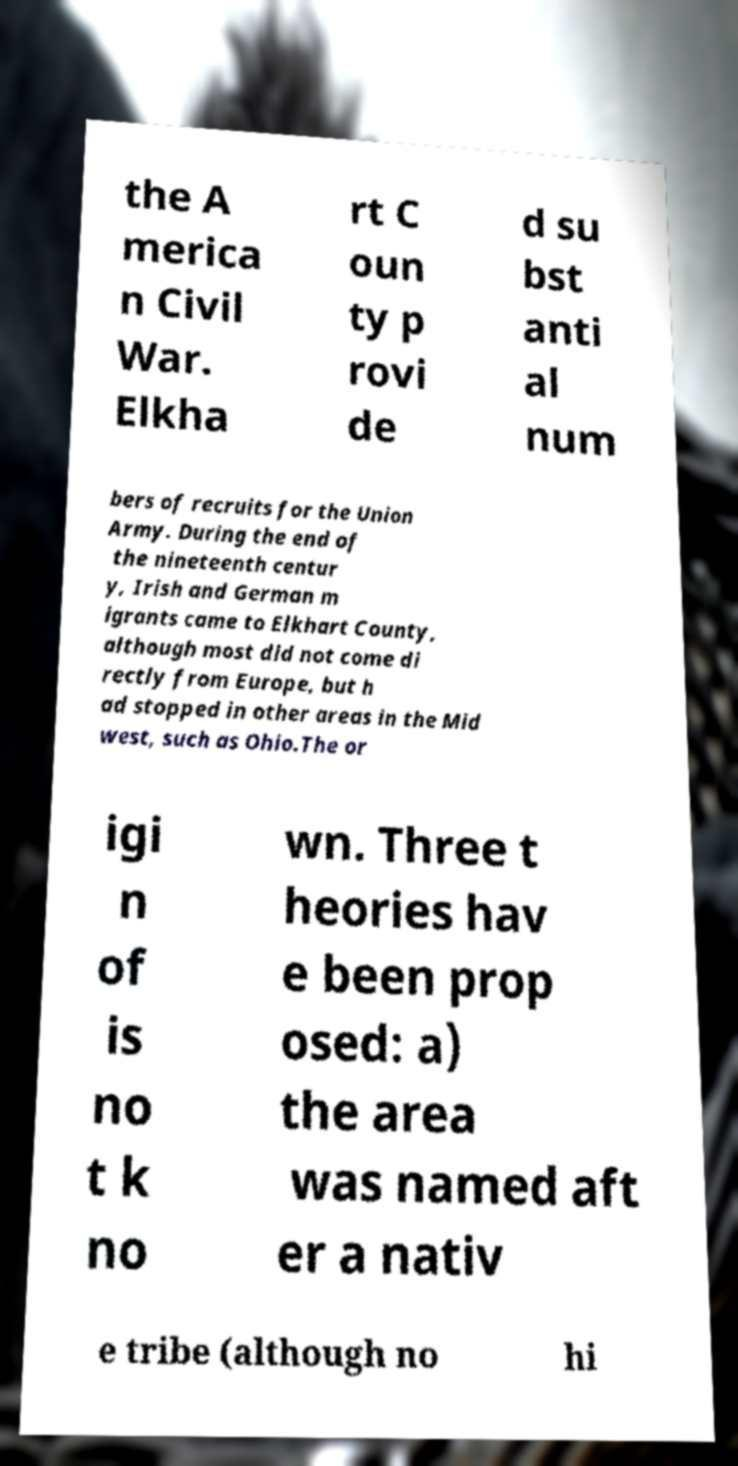I need the written content from this picture converted into text. Can you do that? the A merica n Civil War. Elkha rt C oun ty p rovi de d su bst anti al num bers of recruits for the Union Army. During the end of the nineteenth centur y, Irish and German m igrants came to Elkhart County, although most did not come di rectly from Europe, but h ad stopped in other areas in the Mid west, such as Ohio.The or igi n of is no t k no wn. Three t heories hav e been prop osed: a) the area was named aft er a nativ e tribe (although no hi 